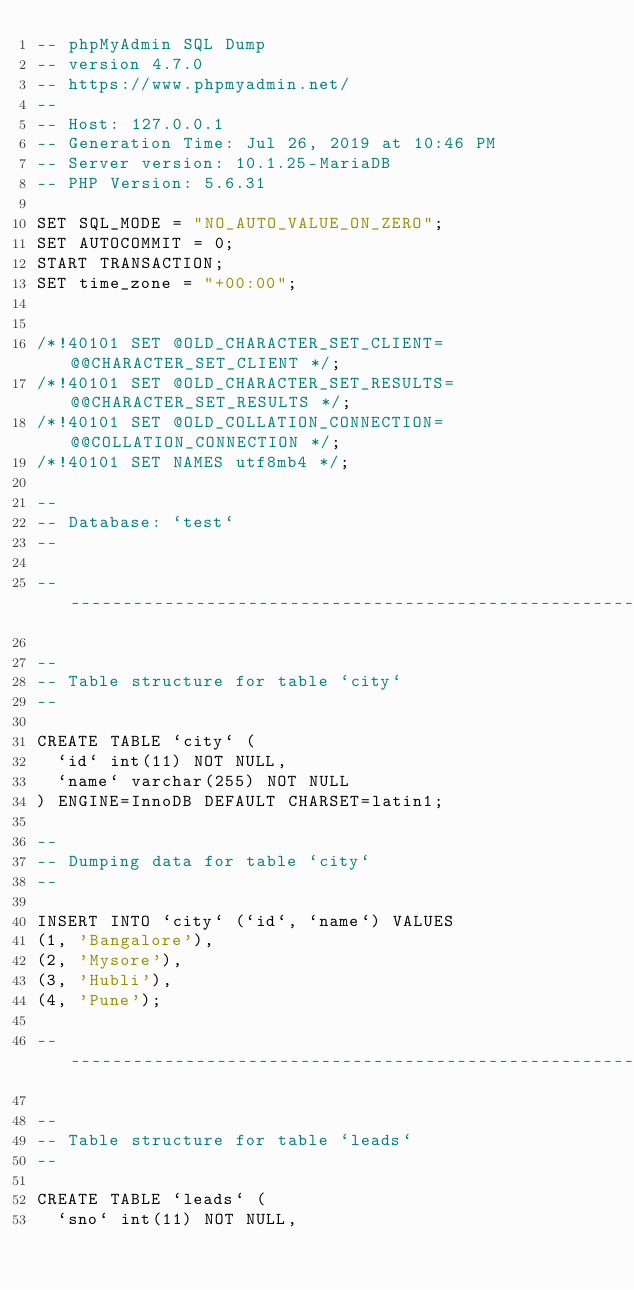Convert code to text. <code><loc_0><loc_0><loc_500><loc_500><_SQL_>-- phpMyAdmin SQL Dump
-- version 4.7.0
-- https://www.phpmyadmin.net/
--
-- Host: 127.0.0.1
-- Generation Time: Jul 26, 2019 at 10:46 PM
-- Server version: 10.1.25-MariaDB
-- PHP Version: 5.6.31

SET SQL_MODE = "NO_AUTO_VALUE_ON_ZERO";
SET AUTOCOMMIT = 0;
START TRANSACTION;
SET time_zone = "+00:00";


/*!40101 SET @OLD_CHARACTER_SET_CLIENT=@@CHARACTER_SET_CLIENT */;
/*!40101 SET @OLD_CHARACTER_SET_RESULTS=@@CHARACTER_SET_RESULTS */;
/*!40101 SET @OLD_COLLATION_CONNECTION=@@COLLATION_CONNECTION */;
/*!40101 SET NAMES utf8mb4 */;

--
-- Database: `test`
--

-- --------------------------------------------------------

--
-- Table structure for table `city`
--

CREATE TABLE `city` (
  `id` int(11) NOT NULL,
  `name` varchar(255) NOT NULL
) ENGINE=InnoDB DEFAULT CHARSET=latin1;

--
-- Dumping data for table `city`
--

INSERT INTO `city` (`id`, `name`) VALUES
(1, 'Bangalore'),
(2, 'Mysore'),
(3, 'Hubli'),
(4, 'Pune');

-- --------------------------------------------------------

--
-- Table structure for table `leads`
--

CREATE TABLE `leads` (
  `sno` int(11) NOT NULL,</code> 